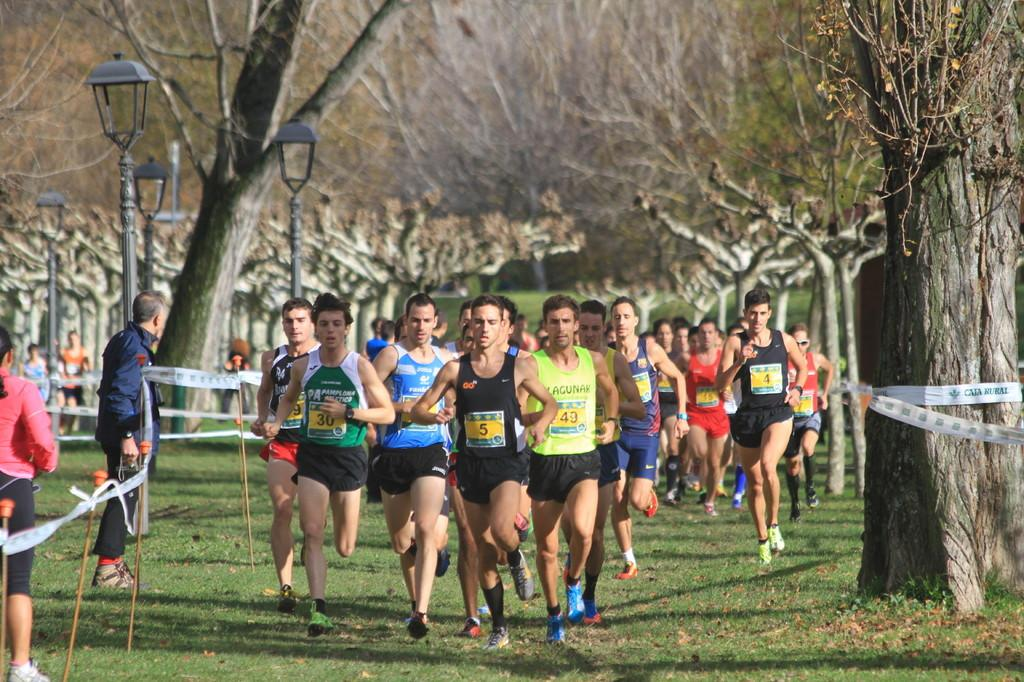How many people are in the image? There are people in the image, but the exact number is not specified. What are some of the people doing in the image? Some people are running in the image. What can be seen in the image besides people? There are poles, lights, trees, and grass on the ground in the image. What type of book is being read in the lunchroom in the image? There is no lunchroom or book present in the image. What kind of war is depicted in the image? There is no war or any indication of conflict in the image. 